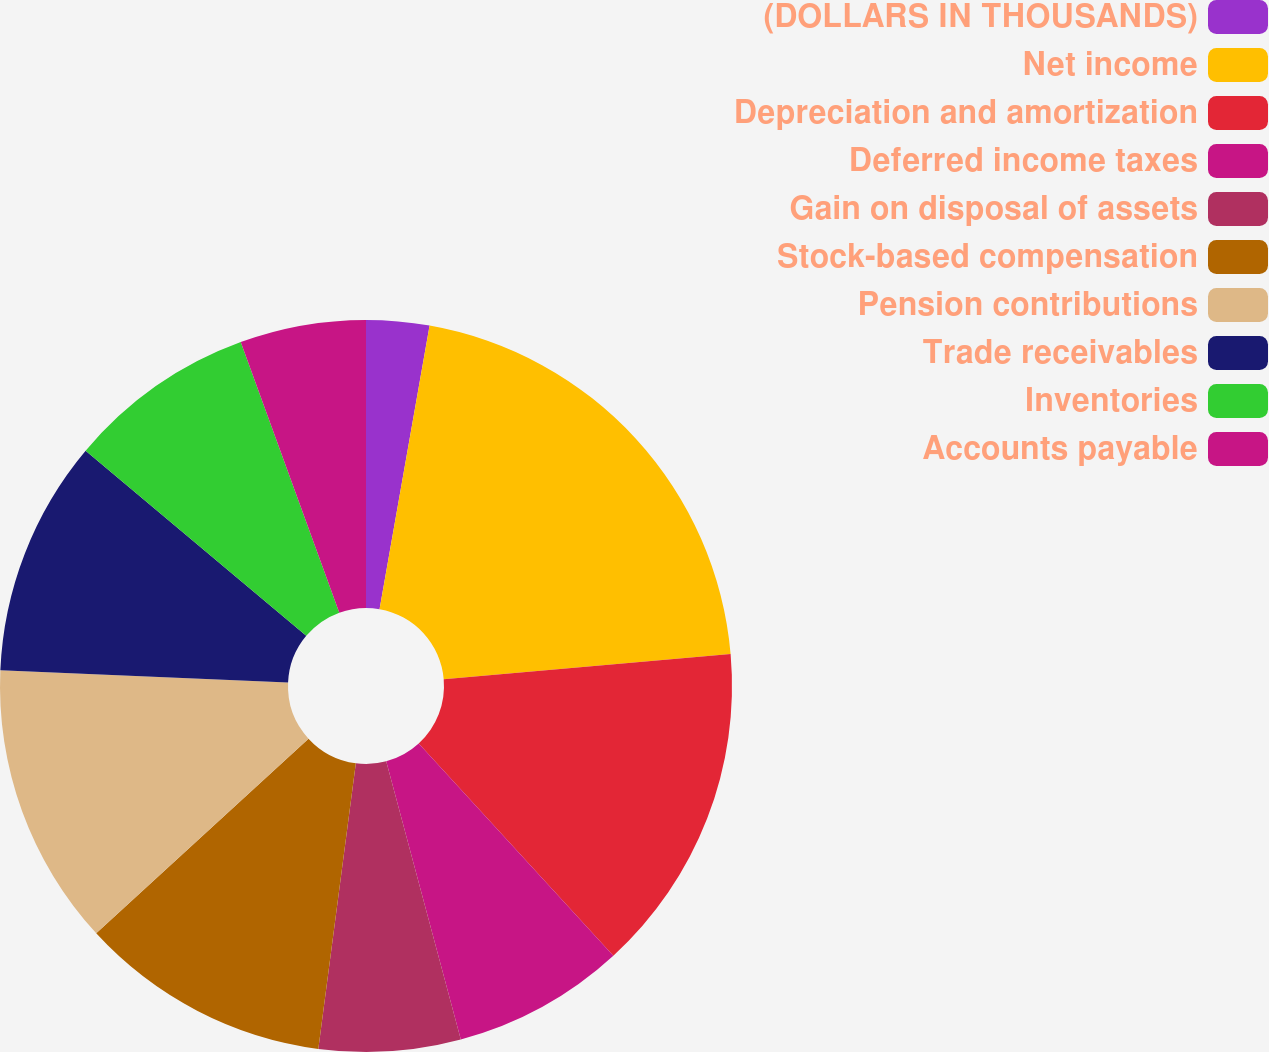Convert chart to OTSL. <chart><loc_0><loc_0><loc_500><loc_500><pie_chart><fcel>(DOLLARS IN THOUSANDS)<fcel>Net income<fcel>Depreciation and amortization<fcel>Deferred income taxes<fcel>Gain on disposal of assets<fcel>Stock-based compensation<fcel>Pension contributions<fcel>Trade receivables<fcel>Inventories<fcel>Accounts payable<nl><fcel>2.78%<fcel>20.83%<fcel>14.58%<fcel>7.64%<fcel>6.25%<fcel>11.11%<fcel>12.5%<fcel>10.42%<fcel>8.33%<fcel>5.56%<nl></chart> 